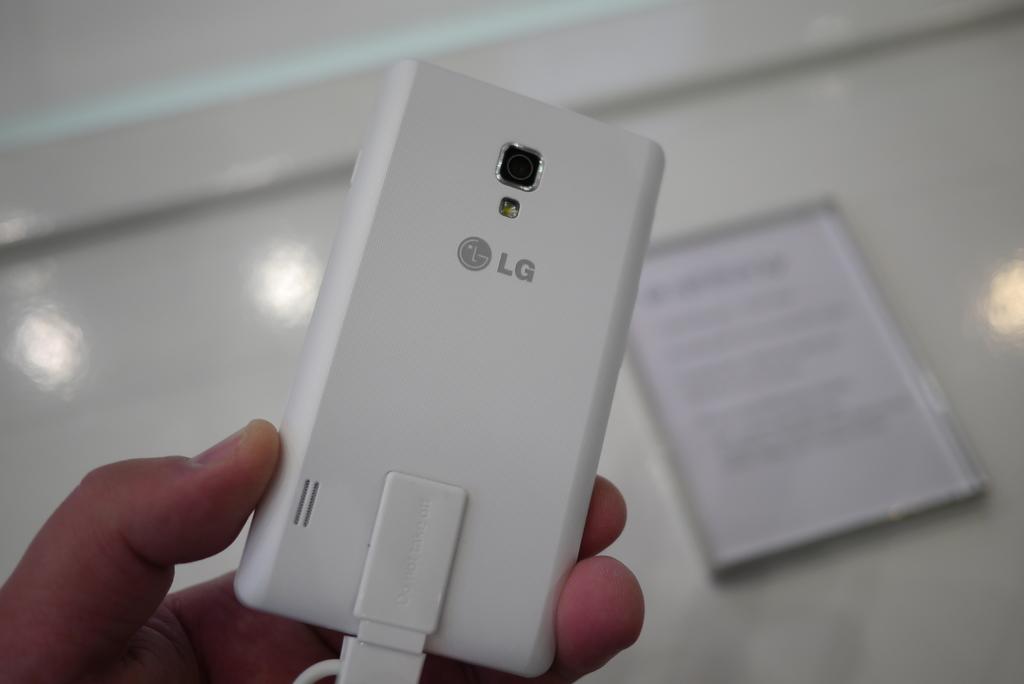What brand is this?
Ensure brevity in your answer.  Lg. This is lg mobile?
Provide a succinct answer. Yes. 